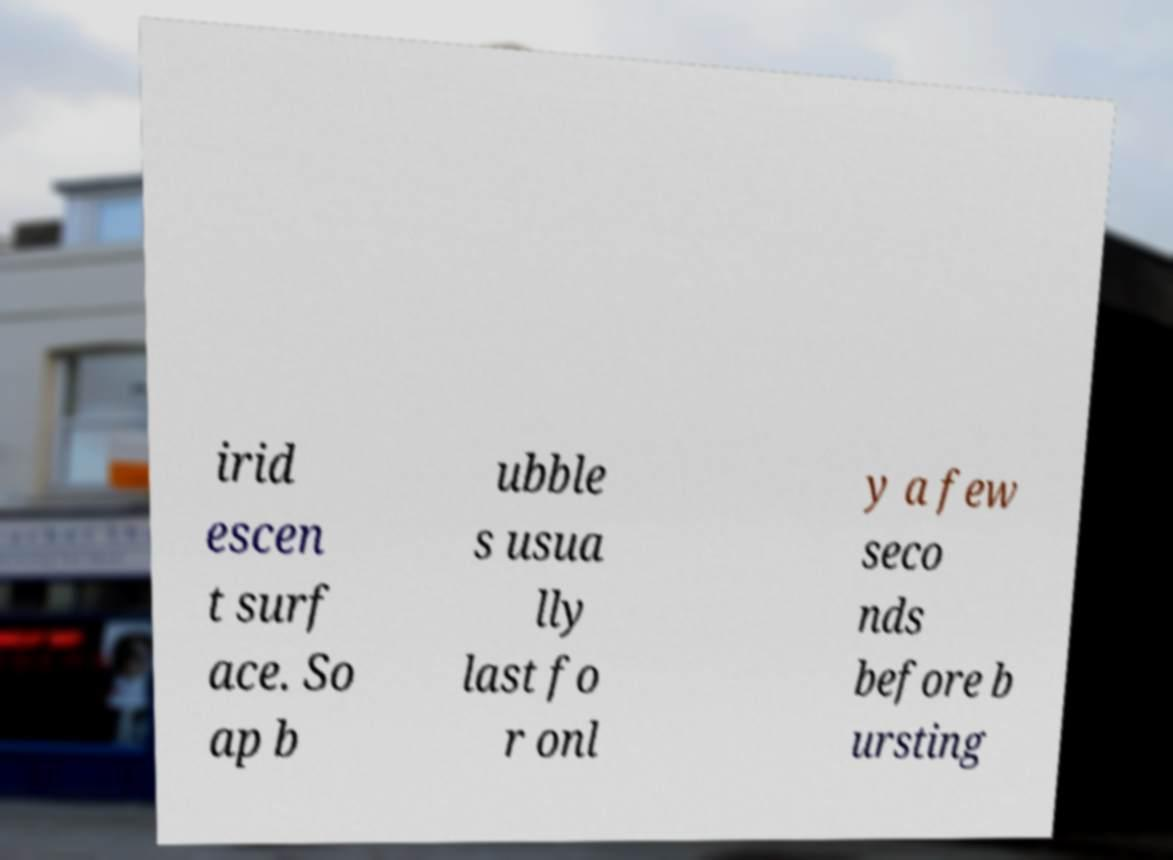There's text embedded in this image that I need extracted. Can you transcribe it verbatim? irid escen t surf ace. So ap b ubble s usua lly last fo r onl y a few seco nds before b ursting 